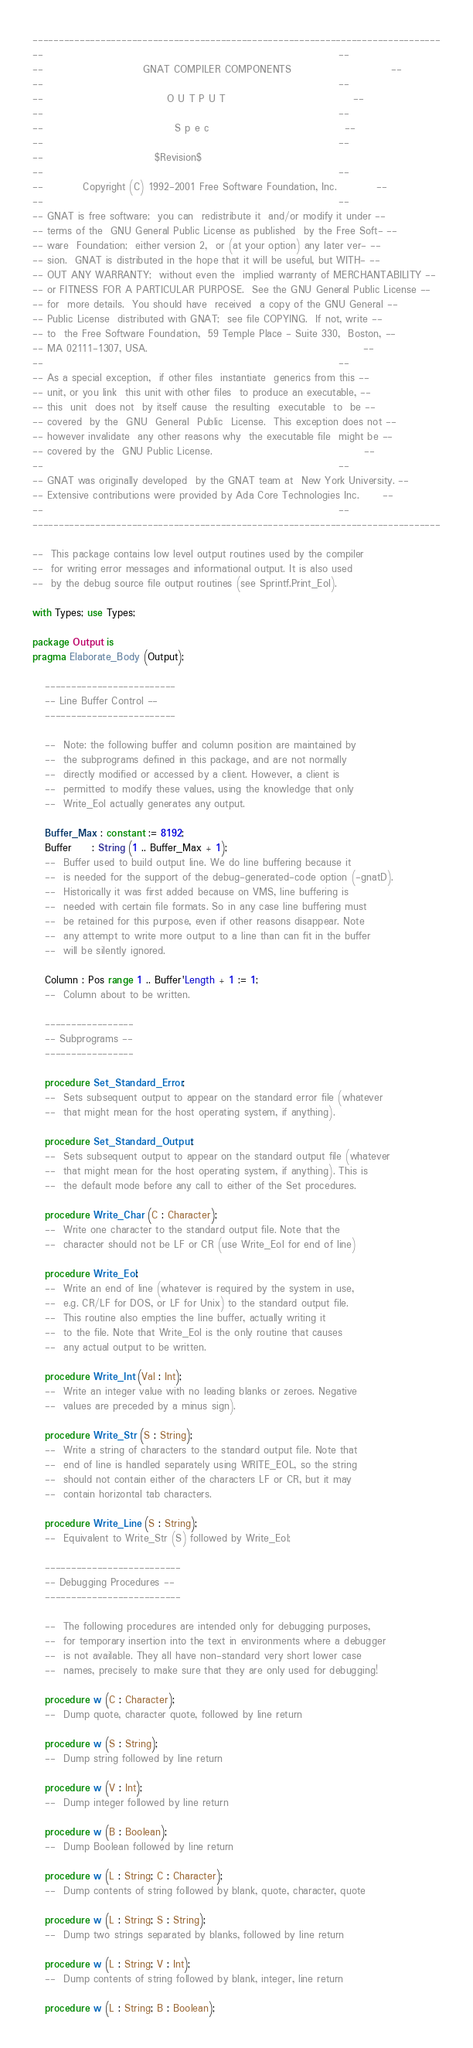<code> <loc_0><loc_0><loc_500><loc_500><_Ada_>------------------------------------------------------------------------------
--                                                                          --
--                         GNAT COMPILER COMPONENTS                         --
--                                                                          --
--                               O U T P U T                                --
--                                                                          --
--                                 S p e c                                  --
--                                                                          --
--                            $Revision$
--                                                                          --
--          Copyright (C) 1992-2001 Free Software Foundation, Inc.          --
--                                                                          --
-- GNAT is free software;  you can  redistribute it  and/or modify it under --
-- terms of the  GNU General Public License as published  by the Free Soft- --
-- ware  Foundation;  either version 2,  or (at your option) any later ver- --
-- sion.  GNAT is distributed in the hope that it will be useful, but WITH- --
-- OUT ANY WARRANTY;  without even the  implied warranty of MERCHANTABILITY --
-- or FITNESS FOR A PARTICULAR PURPOSE.  See the GNU General Public License --
-- for  more details.  You should have  received  a copy of the GNU General --
-- Public License  distributed with GNAT;  see file COPYING.  If not, write --
-- to  the Free Software Foundation,  59 Temple Place - Suite 330,  Boston, --
-- MA 02111-1307, USA.                                                      --
--                                                                          --
-- As a special exception,  if other files  instantiate  generics from this --
-- unit, or you link  this unit with other files  to produce an executable, --
-- this  unit  does not  by itself cause  the resulting  executable  to  be --
-- covered  by the  GNU  General  Public  License.  This exception does not --
-- however invalidate  any other reasons why  the executable file  might be --
-- covered by the  GNU Public License.                                      --
--                                                                          --
-- GNAT was originally developed  by the GNAT team at  New York University. --
-- Extensive contributions were provided by Ada Core Technologies Inc.      --
--                                                                          --
------------------------------------------------------------------------------

--  This package contains low level output routines used by the compiler
--  for writing error messages and informational output. It is also used
--  by the debug source file output routines (see Sprintf.Print_Eol).

with Types; use Types;

package Output is
pragma Elaborate_Body (Output);

   -------------------------
   -- Line Buffer Control --
   -------------------------

   --  Note: the following buffer and column position are maintained by
   --  the subprograms defined in this package, and are not normally
   --  directly modified or accessed by a client. However, a client is
   --  permitted to modify these values, using the knowledge that only
   --  Write_Eol actually generates any output.

   Buffer_Max : constant := 8192;
   Buffer     : String (1 .. Buffer_Max + 1);
   --  Buffer used to build output line. We do line buffering because it
   --  is needed for the support of the debug-generated-code option (-gnatD).
   --  Historically it was first added because on VMS, line buffering is
   --  needed with certain file formats. So in any case line buffering must
   --  be retained for this purpose, even if other reasons disappear. Note
   --  any attempt to write more output to a line than can fit in the buffer
   --  will be silently ignored.

   Column : Pos range 1 .. Buffer'Length + 1 := 1;
   --  Column about to be written.

   -----------------
   -- Subprograms --
   -----------------

   procedure Set_Standard_Error;
   --  Sets subsequent output to appear on the standard error file (whatever
   --  that might mean for the host operating system, if anything).

   procedure Set_Standard_Output;
   --  Sets subsequent output to appear on the standard output file (whatever
   --  that might mean for the host operating system, if anything). This is
   --  the default mode before any call to either of the Set procedures.

   procedure Write_Char (C : Character);
   --  Write one character to the standard output file. Note that the
   --  character should not be LF or CR (use Write_Eol for end of line)

   procedure Write_Eol;
   --  Write an end of line (whatever is required by the system in use,
   --  e.g. CR/LF for DOS, or LF for Unix) to the standard output file.
   --  This routine also empties the line buffer, actually writing it
   --  to the file. Note that Write_Eol is the only routine that causes
   --  any actual output to be written.

   procedure Write_Int (Val : Int);
   --  Write an integer value with no leading blanks or zeroes. Negative
   --  values are preceded by a minus sign).

   procedure Write_Str (S : String);
   --  Write a string of characters to the standard output file. Note that
   --  end of line is handled separately using WRITE_EOL, so the string
   --  should not contain either of the characters LF or CR, but it may
   --  contain horizontal tab characters.

   procedure Write_Line (S : String);
   --  Equivalent to Write_Str (S) followed by Write_Eol;

   --------------------------
   -- Debugging Procedures --
   --------------------------

   --  The following procedures are intended only for debugging purposes,
   --  for temporary insertion into the text in environments where a debugger
   --  is not available. They all have non-standard very short lower case
   --  names, precisely to make sure that they are only used for debugging!

   procedure w (C : Character);
   --  Dump quote, character quote, followed by line return

   procedure w (S : String);
   --  Dump string followed by line return

   procedure w (V : Int);
   --  Dump integer followed by line return

   procedure w (B : Boolean);
   --  Dump Boolean followed by line return

   procedure w (L : String; C : Character);
   --  Dump contents of string followed by blank, quote, character, quote

   procedure w (L : String; S : String);
   --  Dump two strings separated by blanks, followed by line return

   procedure w (L : String; V : Int);
   --  Dump contents of string followed by blank, integer, line return

   procedure w (L : String; B : Boolean);</code> 